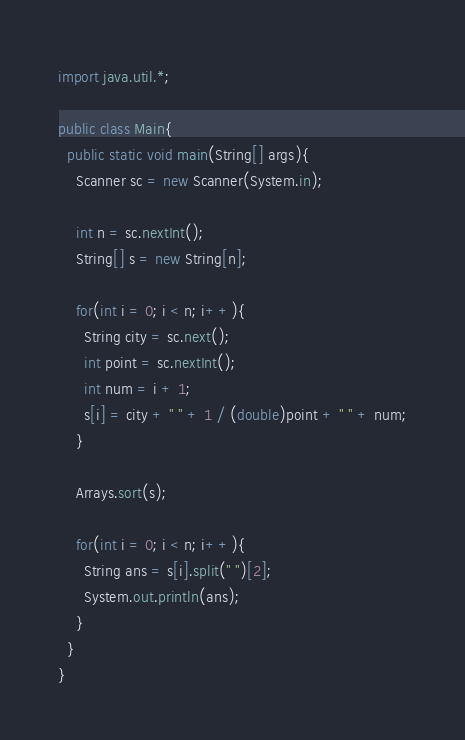<code> <loc_0><loc_0><loc_500><loc_500><_Java_>import java.util.*;

public class Main{
  public static void main(String[] args){
    Scanner sc = new Scanner(System.in);

    int n = sc.nextInt();
    String[] s = new String[n];

    for(int i = 0; i < n; i++){
      String city = sc.next();
      int point = sc.nextInt();
      int num = i + 1;
      s[i] = city + " " + 1 / (double)point + " " + num;
    }

    Arrays.sort(s);

    for(int i = 0; i < n; i++){
      String ans = s[i].split(" ")[2];
      System.out.println(ans);
    }
  }
}
</code> 